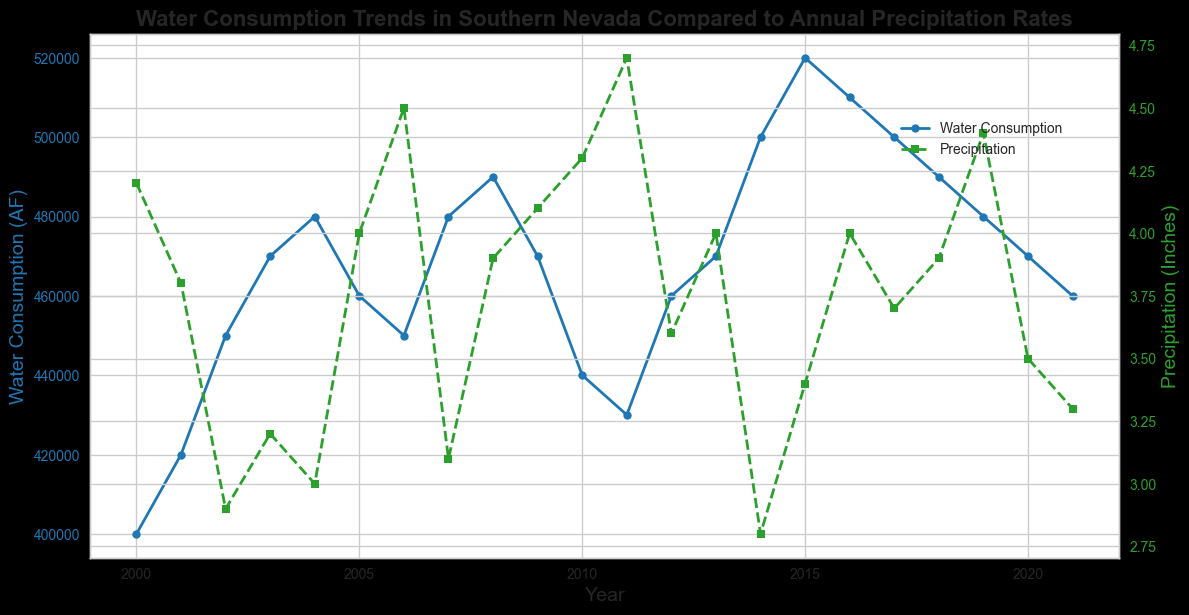What is the overall trend in the water consumption over the years from 2000 to 2021? By visually inspecting the blue line representing Water Consumption, it generally trends upward from 2000 to 2021, with some minor fluctuations.
Answer: Upward trend During which year was the water consumption the highest, and what was the amount? The highest point on the blue line corresponds to the year 2015, where water consumption reached 520,000 AF.
Answer: 2015, 520,000 AF How does the precipitation in 2020 compare to 2005? By looking at the green line for Precipitation, in 2005, it was about 4.0 inches, and in 2020, it was about 3.5 inches. Therefore, precipitation in 2020 was less than in 2005.
Answer: Less in 2020 Calculate the average water consumption between 2000 and 2021. Sum the Water Consumption values from 2000 to 2021, then divide by the number of years (22). Total Water Consumption = 9,530,000 AF; Average = 9,530,000 / 22 ≈ 433,182 AF
Answer: ≈ 433,182 AF What year had the least rainfall, and what was the amount? The lowest point on the green line is in 2002, where precipitation was 2.9 inches.
Answer: 2002, 2.9 inches Is there a visible correlation between water consumption and precipitation? By comparing the blue and green lines, there does not appear to be a strong visual correlation; water consumption generally increases whereas precipitation fluctuates with no clear trend.
Answer: No clear correlation In which year did water consumption show the most significant increase compared to the previous year? The most significant increase is between 2014 and 2015, where water consumption increased from 500,000 AF to 520,000 AF, by 20,000 AF.
Answer: 2015 What was the precipitation difference between the years 2011 and 2014? In 2011, the precipitation was 4.7 inches, and in 2014 it was 2.8 inches. The difference is 4.7 - 2.8 = 1.9 inches.
Answer: 1.9 inches Did water consumption ever decrease in consecutive years? If so, when? By following the blue line, water consumption decreased from 2004 to 2005, 2008 to 2009, and 2010 to 2011.
Answer: 2004-2005, 2008-2009, 2010-2011 Which year had higher precipitation: 2006 or 2016? By comparing the green markers, 2006 has slightly higher precipitation (~4.5 inches) than 2016 (~4.0 inches).
Answer: 2006 